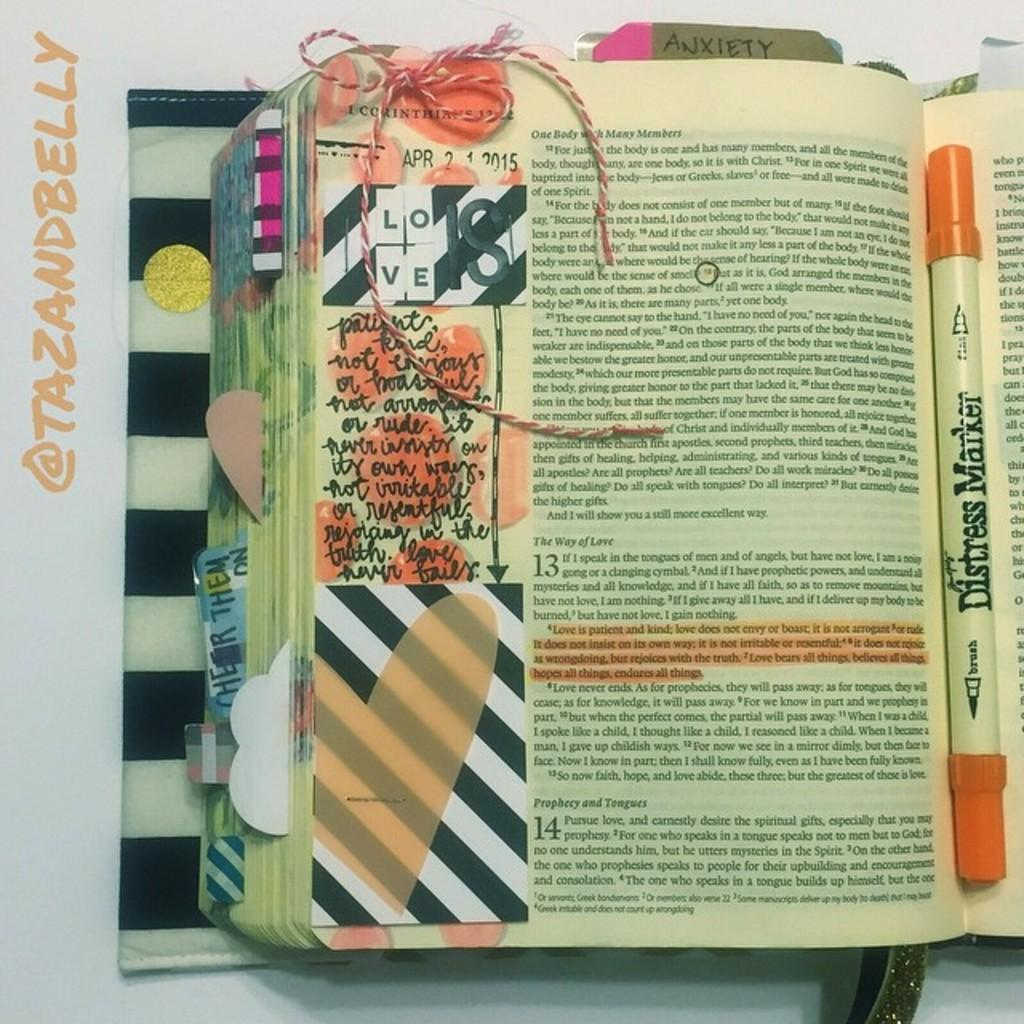<image>
Share a concise interpretation of the image provided. A page of a book is marked up with a "distress marker." 